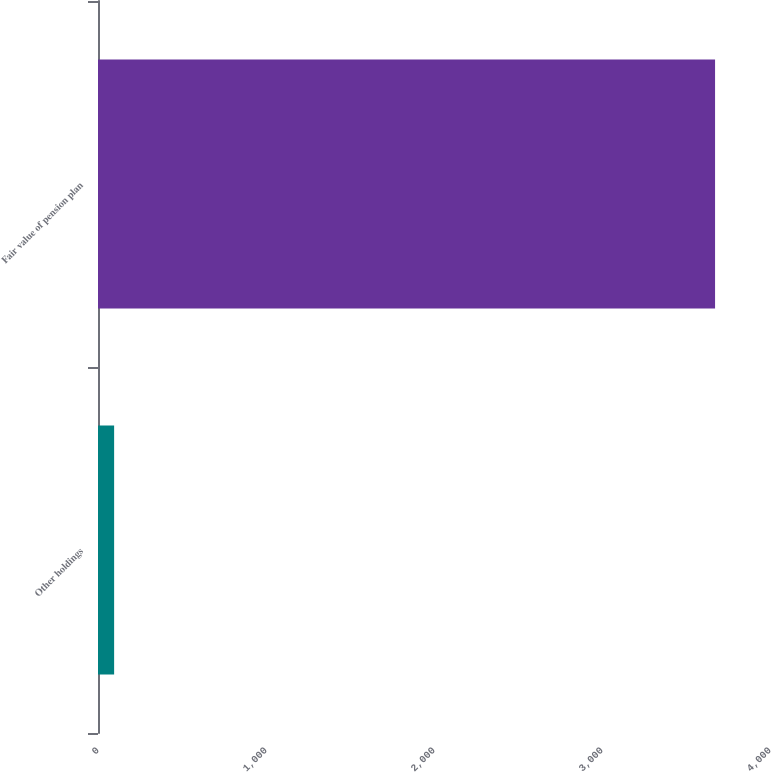Convert chart. <chart><loc_0><loc_0><loc_500><loc_500><bar_chart><fcel>Other holdings<fcel>Fair value of pension plan<nl><fcel>96<fcel>3673<nl></chart> 